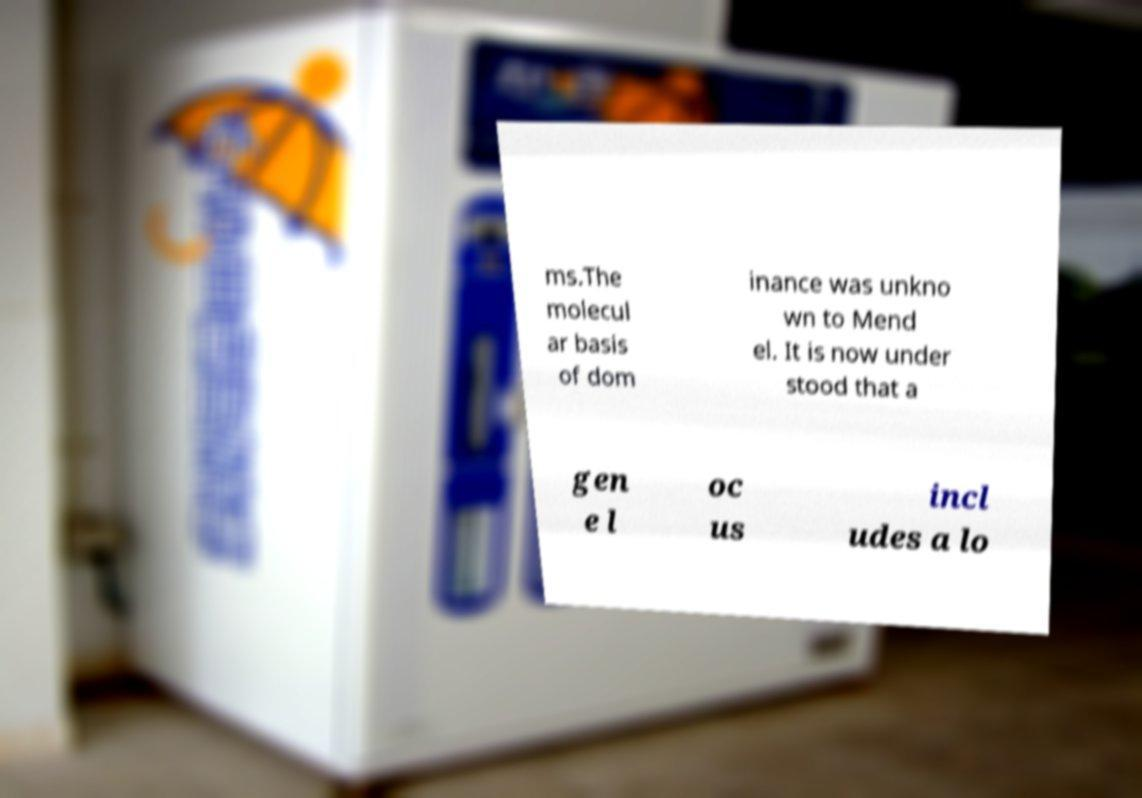Can you accurately transcribe the text from the provided image for me? ms.The molecul ar basis of dom inance was unkno wn to Mend el. It is now under stood that a gen e l oc us incl udes a lo 